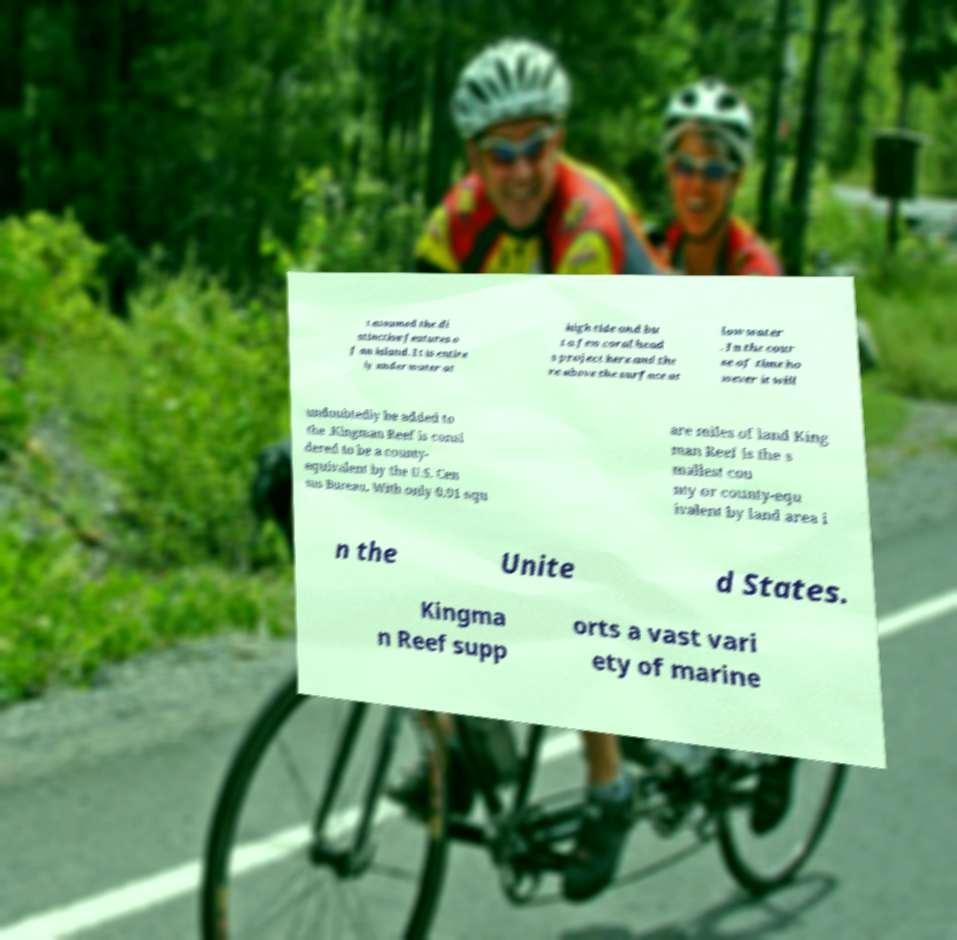For documentation purposes, I need the text within this image transcribed. Could you provide that? t assumed the di stinctive features o f an island. It is entire ly under water at high tide and bu t a few coral head s project here and the re above the surface at low water . In the cour se of time ho wever it will undoubtedly be added to the .Kingman Reef is consi dered to be a county- equivalent by the U.S. Cen sus Bureau. With only 0.01 squ are miles of land King man Reef is the s mallest cou nty or county-equ ivalent by land area i n the Unite d States. Kingma n Reef supp orts a vast vari ety of marine 